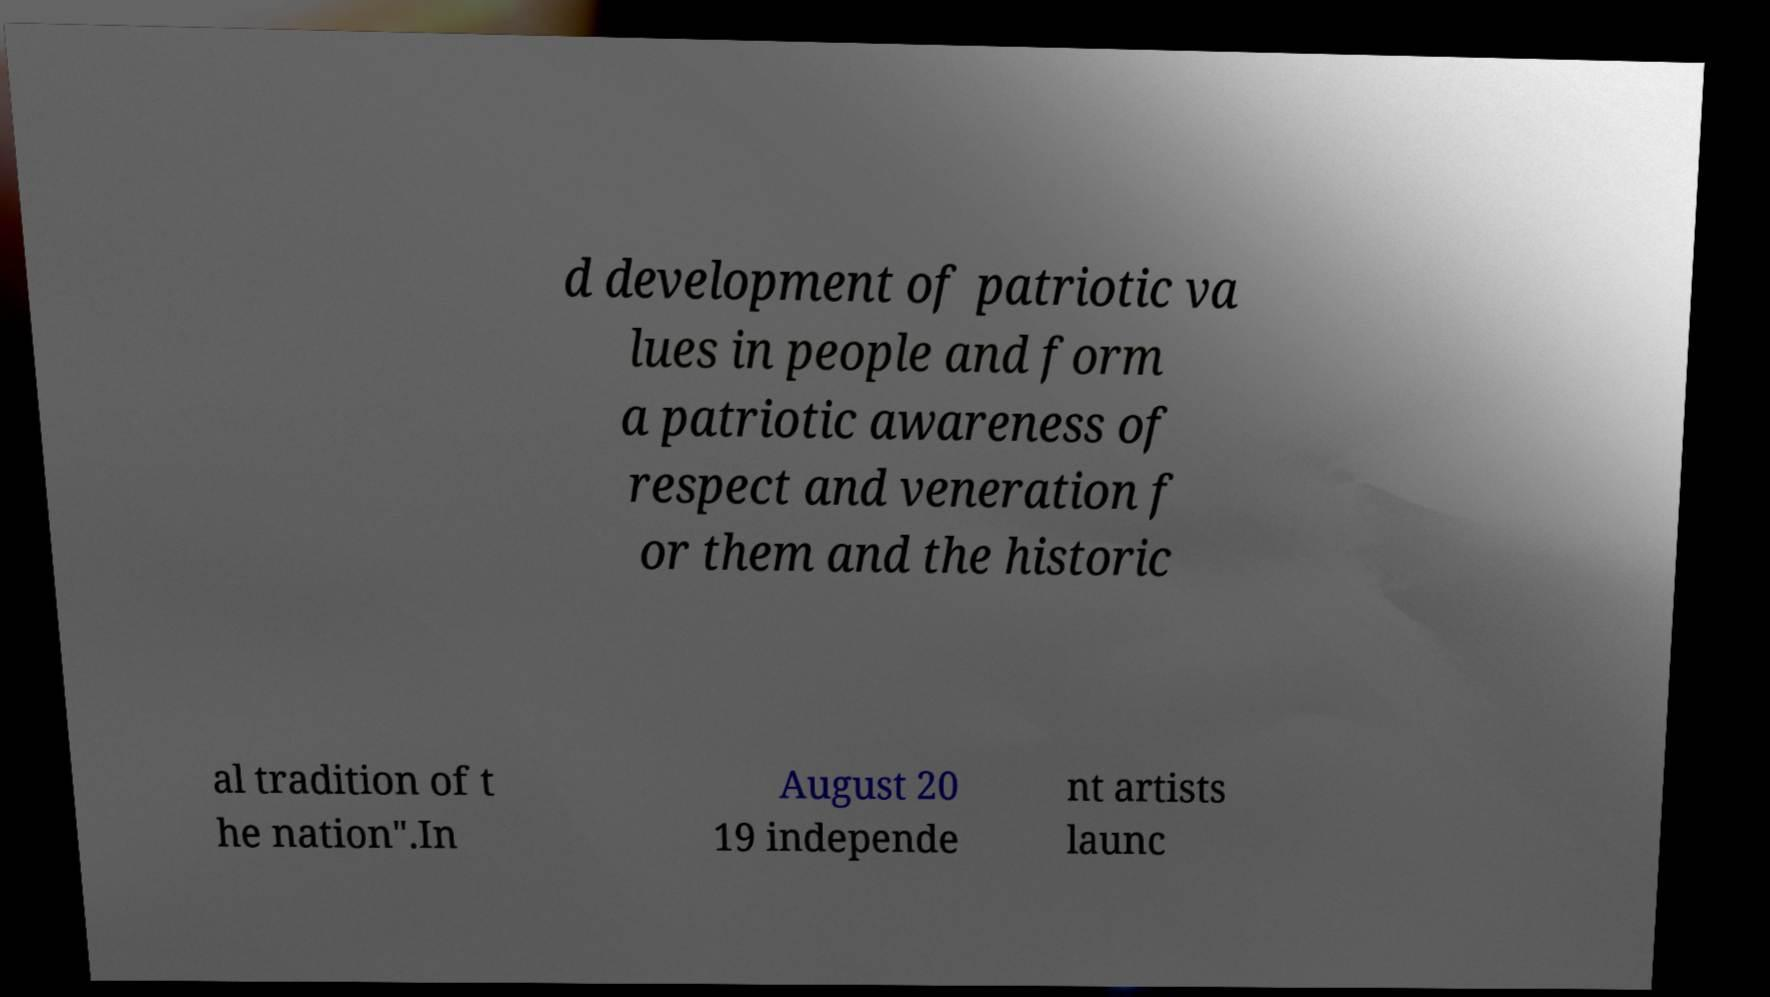Please read and relay the text visible in this image. What does it say? d development of patriotic va lues in people and form a patriotic awareness of respect and veneration f or them and the historic al tradition of t he nation".In August 20 19 independe nt artists launc 